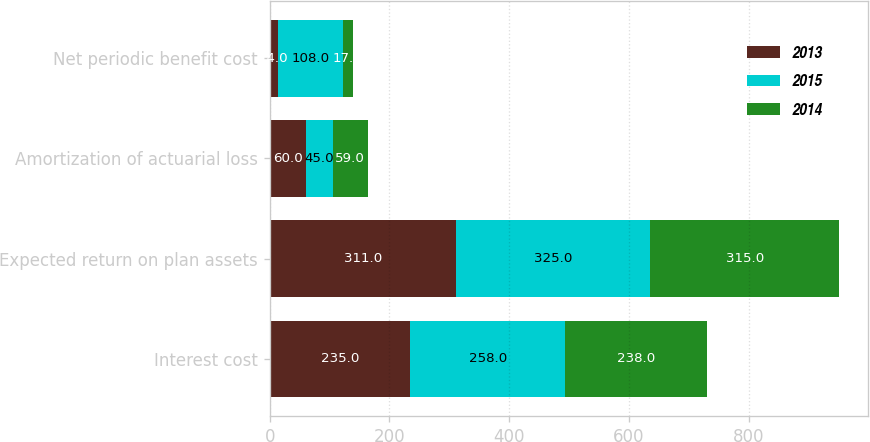Convert chart to OTSL. <chart><loc_0><loc_0><loc_500><loc_500><stacked_bar_chart><ecel><fcel>Interest cost<fcel>Expected return on plan assets<fcel>Amortization of actuarial loss<fcel>Net periodic benefit cost<nl><fcel>2013<fcel>235<fcel>311<fcel>60<fcel>14<nl><fcel>2015<fcel>258<fcel>325<fcel>45<fcel>108<nl><fcel>2014<fcel>238<fcel>315<fcel>59<fcel>17<nl></chart> 